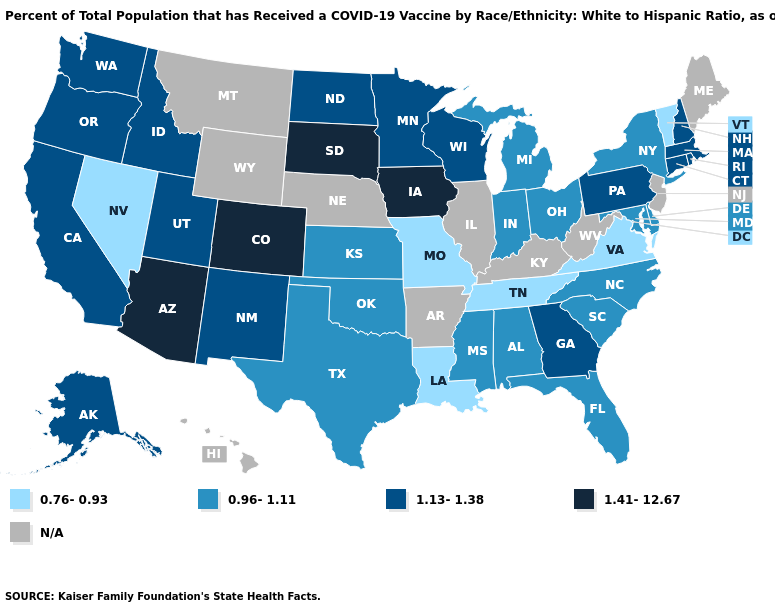Name the states that have a value in the range 1.13-1.38?
Quick response, please. Alaska, California, Connecticut, Georgia, Idaho, Massachusetts, Minnesota, New Hampshire, New Mexico, North Dakota, Oregon, Pennsylvania, Rhode Island, Utah, Washington, Wisconsin. What is the value of New York?
Write a very short answer. 0.96-1.11. Among the states that border South Dakota , which have the lowest value?
Answer briefly. Minnesota, North Dakota. Name the states that have a value in the range N/A?
Short answer required. Arkansas, Hawaii, Illinois, Kentucky, Maine, Montana, Nebraska, New Jersey, West Virginia, Wyoming. What is the value of Wyoming?
Quick response, please. N/A. What is the lowest value in states that border West Virginia?
Quick response, please. 0.76-0.93. Among the states that border Tennessee , does North Carolina have the highest value?
Concise answer only. No. Name the states that have a value in the range 0.96-1.11?
Give a very brief answer. Alabama, Delaware, Florida, Indiana, Kansas, Maryland, Michigan, Mississippi, New York, North Carolina, Ohio, Oklahoma, South Carolina, Texas. What is the value of Oregon?
Write a very short answer. 1.13-1.38. What is the value of Virginia?
Write a very short answer. 0.76-0.93. How many symbols are there in the legend?
Short answer required. 5. Among the states that border Ohio , does Pennsylvania have the lowest value?
Short answer required. No. What is the value of New Hampshire?
Write a very short answer. 1.13-1.38. What is the value of Georgia?
Quick response, please. 1.13-1.38. 